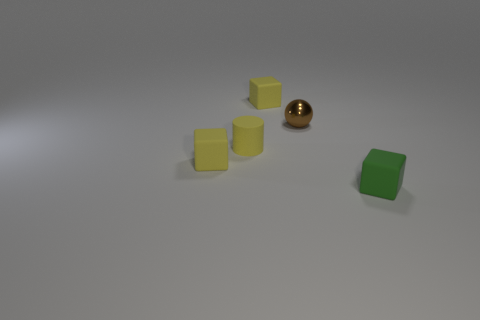What is the size of the green block that is made of the same material as the tiny cylinder?
Offer a very short reply. Small. What number of things are either small yellow matte blocks behind the tiny brown shiny object or tiny matte blocks?
Your answer should be very brief. 3. Do the tiny block that is behind the tiny brown ball and the matte cylinder have the same color?
Your answer should be compact. Yes. There is a rubber block in front of the yellow block that is on the left side of the small yellow matte cube that is to the right of the rubber cylinder; what is its color?
Provide a short and direct response. Green. Does the brown ball have the same material as the yellow cylinder?
Give a very brief answer. No. Are there any rubber things in front of the tiny matte block that is on the left side of the yellow matte thing that is to the right of the small yellow rubber cylinder?
Offer a terse response. Yes. Does the shiny ball have the same color as the cylinder?
Your answer should be compact. No. Are there fewer cyan metal balls than matte things?
Your answer should be very brief. Yes. Are the small yellow cube behind the small yellow matte cylinder and the block that is left of the small yellow cylinder made of the same material?
Offer a very short reply. Yes. Are there fewer tiny matte objects behind the small metal sphere than small matte cubes?
Offer a terse response. Yes. 